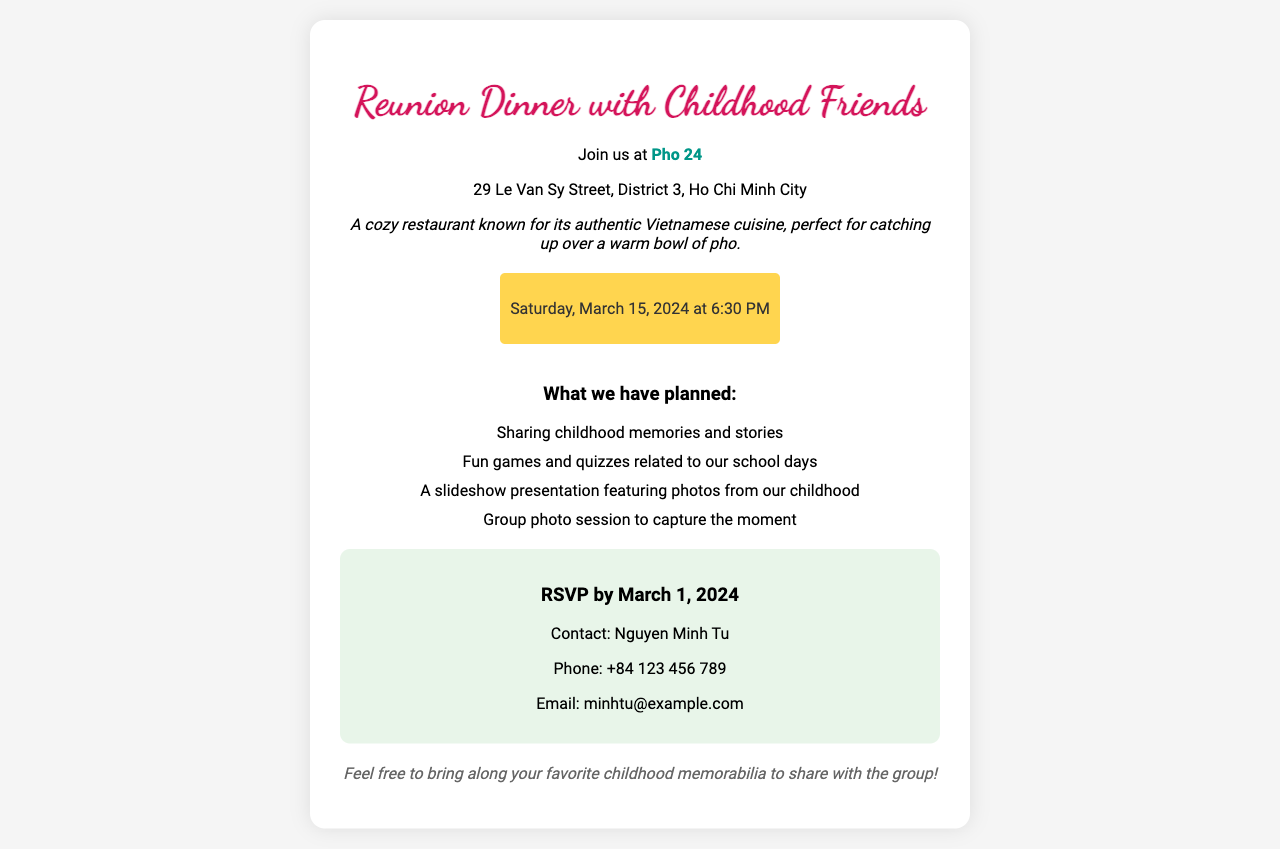What is the name of the restaurant? The name of the restaurant where the reunion dinner will be held is mentioned in the invitation.
Answer: Pho 24 What is the address of the venue? The address provided in the invitation is a specific location in Ho Chi Minh City, highlighting the District and street name.
Answer: 29 Le Van Sy Street, District 3, Ho Chi Minh City What time does the reunion dinner start? The document specifies the time for the reunion dinner, indicating when guests should arrive.
Answer: 6:30 PM On what date is the reunion dinner scheduled? The date for the reunion dinner is clearly stated in the invitation, allowing friends to plan accordingly.
Answer: March 15, 2024 Who should be contacted for RSVP? The invitation indicates a specific person to contact for RSVP, which helps attendees know who to reach out to.
Answer: Nguyen Minh Tu What is one of the planned activities during the reunion? The invitation lists various activities planned, and one can be easily highlighted.
Answer: Sharing childhood memories and stories What is the RSVP deadline date? The document specifies the deadline for confirming attendance at the reunion dinner.
Answer: March 1, 2024 What type of food is the restaurant known for? The invitation describes the restaurant's specialty, providing a view of the dining experience planned for the dinner.
Answer: Authentic Vietnamese cuisine What should guests bring along to the reunion? The invitation encourages attendees to bring something specific to enhance the gathering, which adds a personal touch to the event.
Answer: Childhood memorabilia 